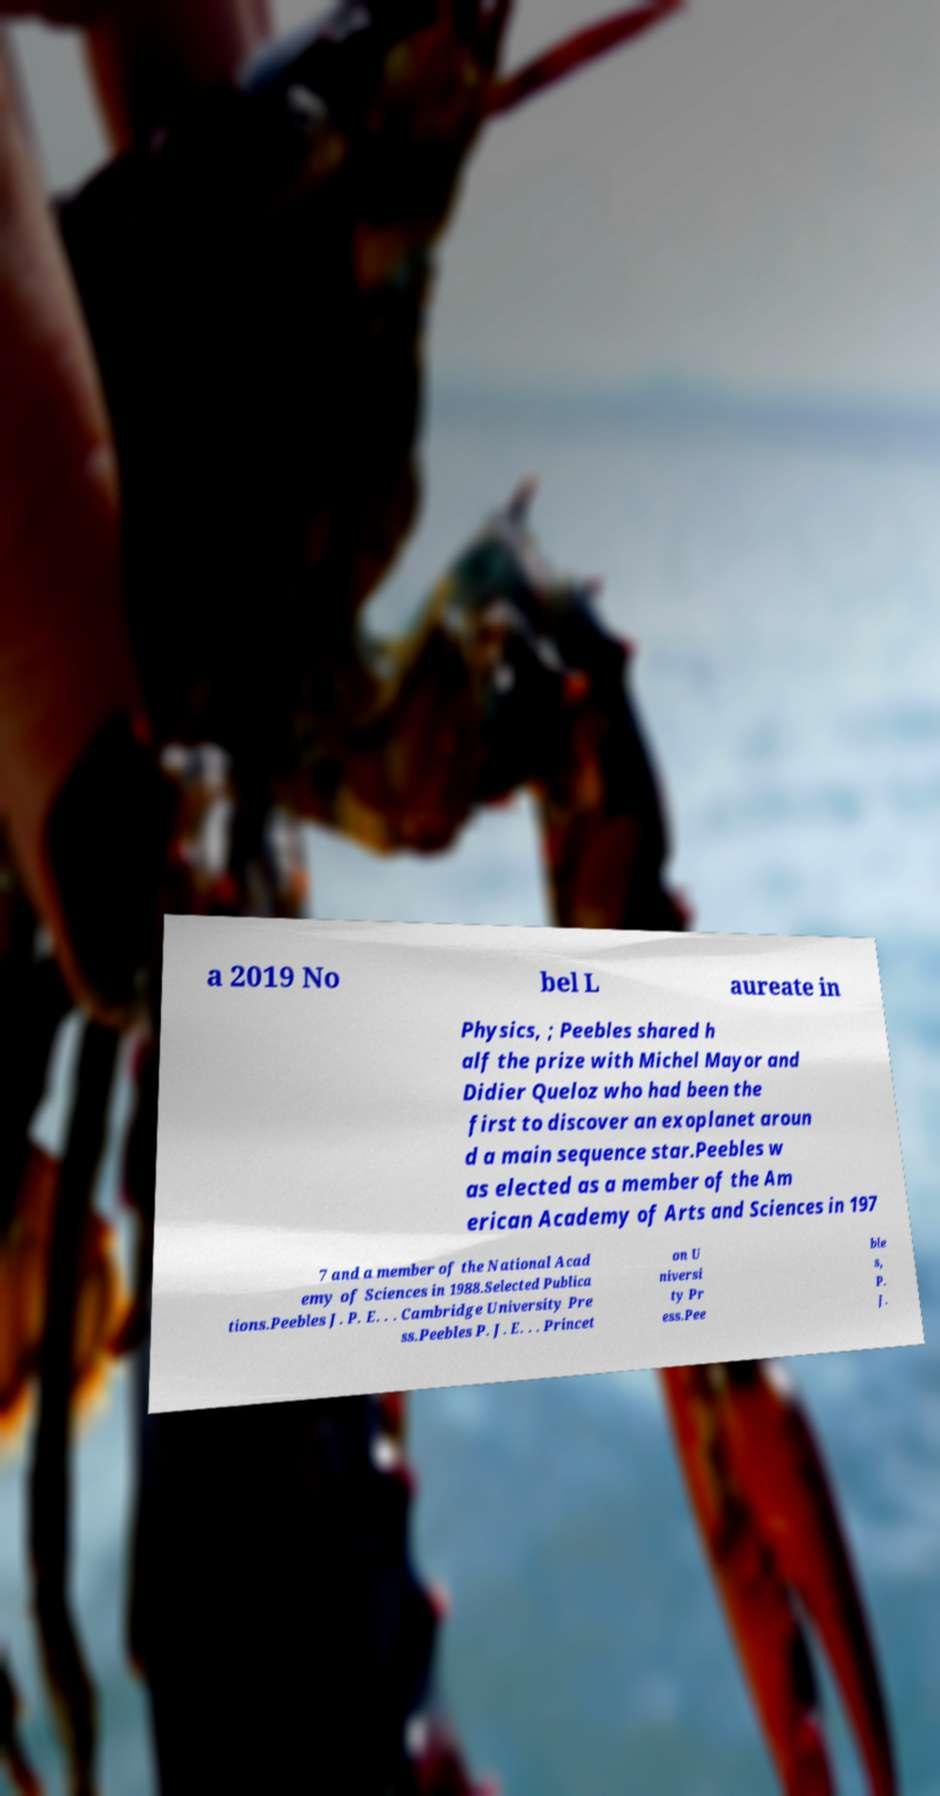I need the written content from this picture converted into text. Can you do that? a 2019 No bel L aureate in Physics, ; Peebles shared h alf the prize with Michel Mayor and Didier Queloz who had been the first to discover an exoplanet aroun d a main sequence star.Peebles w as elected as a member of the Am erican Academy of Arts and Sciences in 197 7 and a member of the National Acad emy of Sciences in 1988.Selected Publica tions.Peebles J. P. E. . . Cambridge University Pre ss.Peebles P. J. E. . . Princet on U niversi ty Pr ess.Pee ble s, P. J. 